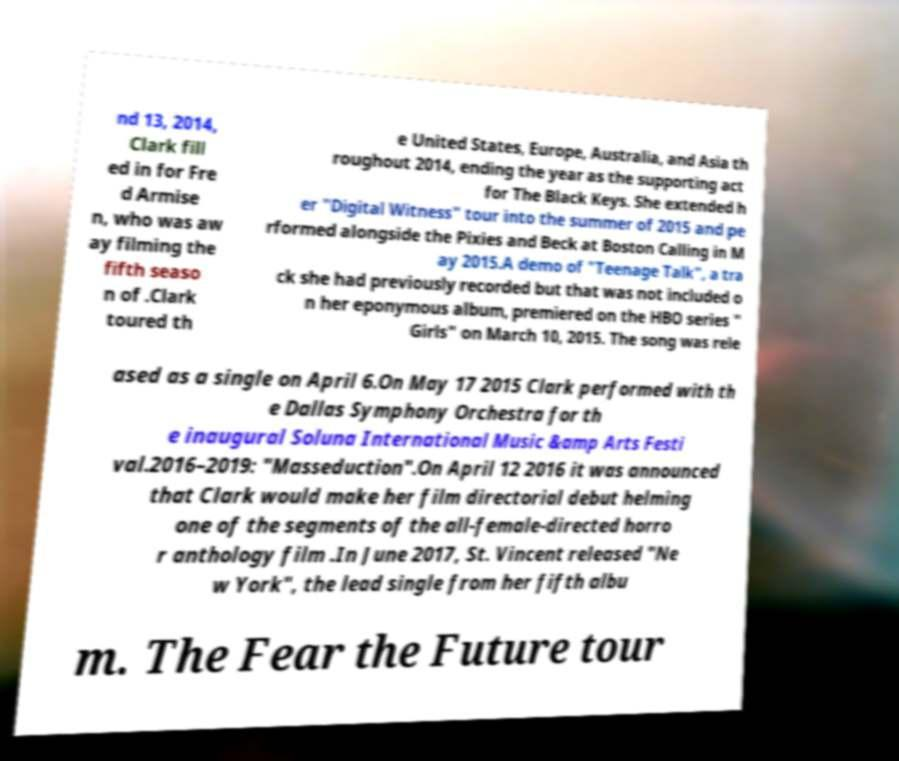Could you assist in decoding the text presented in this image and type it out clearly? nd 13, 2014, Clark fill ed in for Fre d Armise n, who was aw ay filming the fifth seaso n of .Clark toured th e United States, Europe, Australia, and Asia th roughout 2014, ending the year as the supporting act for The Black Keys. She extended h er "Digital Witness" tour into the summer of 2015 and pe rformed alongside the Pixies and Beck at Boston Calling in M ay 2015.A demo of "Teenage Talk", a tra ck she had previously recorded but that was not included o n her eponymous album, premiered on the HBO series " Girls" on March 10, 2015. The song was rele ased as a single on April 6.On May 17 2015 Clark performed with th e Dallas Symphony Orchestra for th e inaugural Soluna International Music &amp Arts Festi val.2016–2019: "Masseduction".On April 12 2016 it was announced that Clark would make her film directorial debut helming one of the segments of the all-female-directed horro r anthology film .In June 2017, St. Vincent released "Ne w York", the lead single from her fifth albu m. The Fear the Future tour 